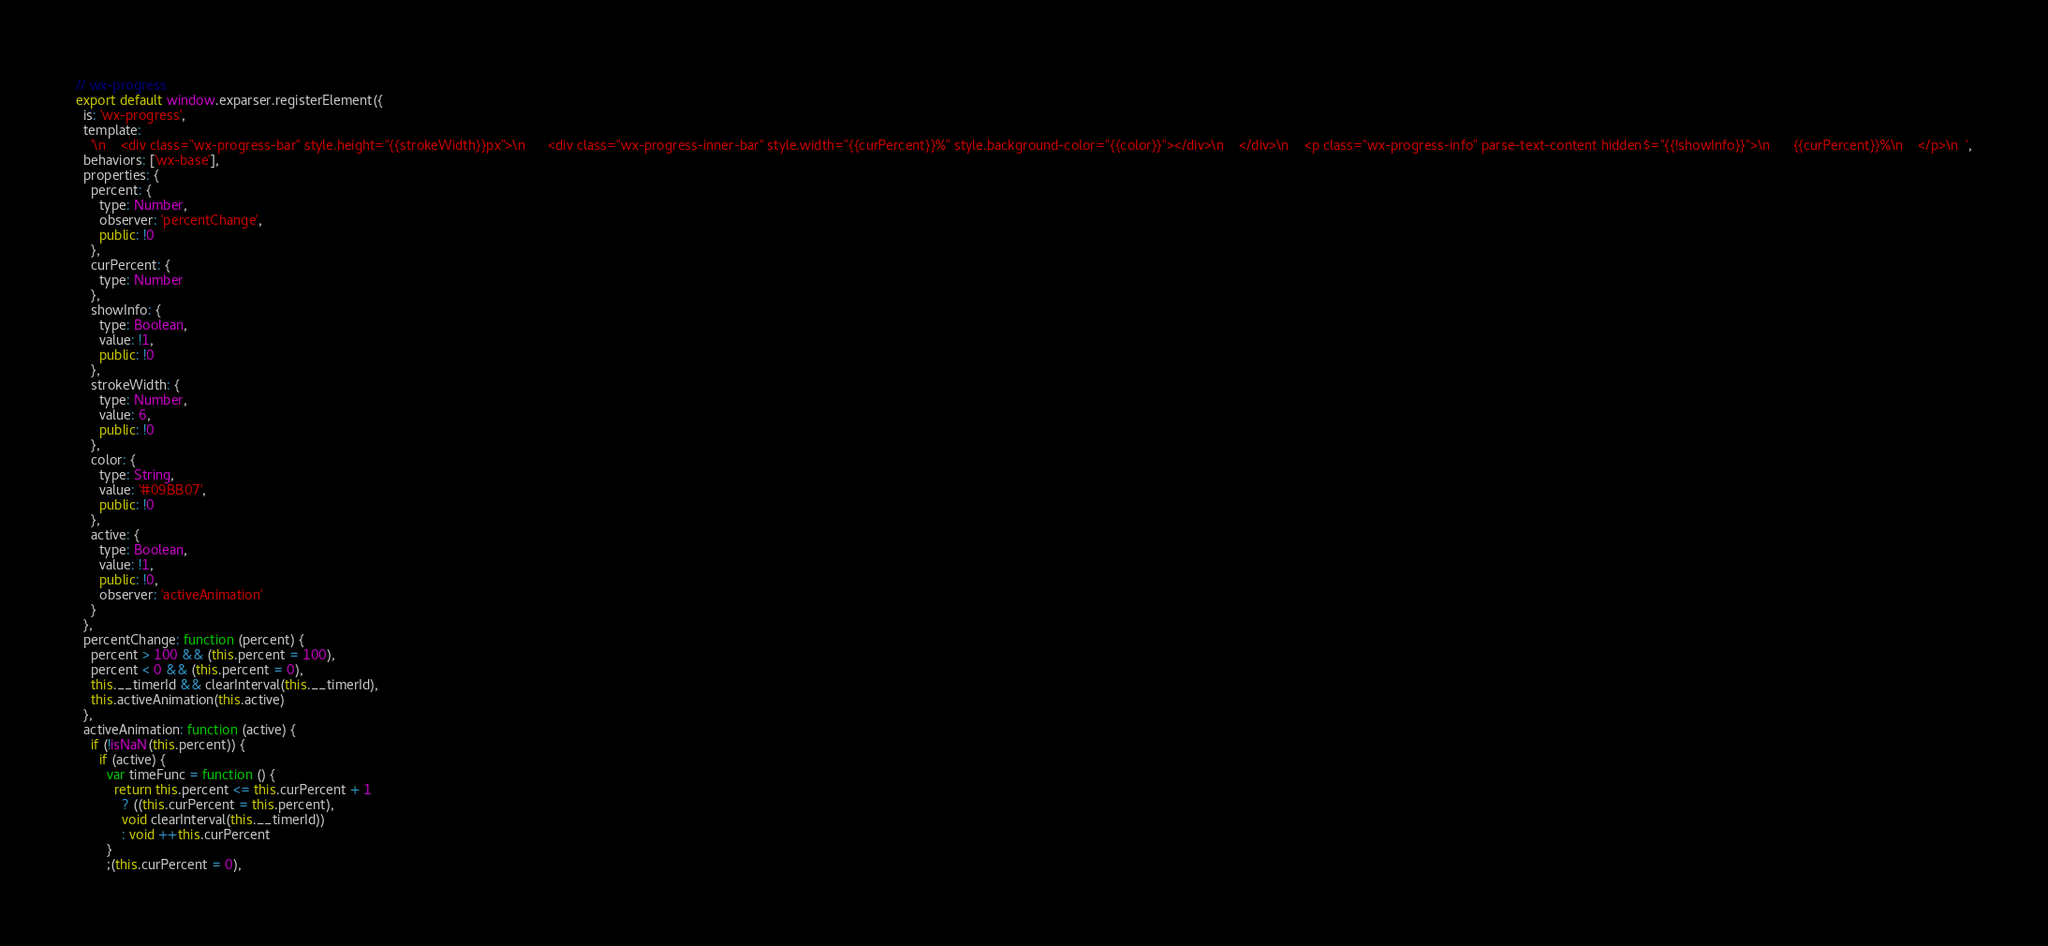<code> <loc_0><loc_0><loc_500><loc_500><_JavaScript_>// wx-progress
export default window.exparser.registerElement({
  is: 'wx-progress',
  template:
    '\n    <div class="wx-progress-bar" style.height="{{strokeWidth}}px">\n      <div class="wx-progress-inner-bar" style.width="{{curPercent}}%" style.background-color="{{color}}"></div>\n    </div>\n    <p class="wx-progress-info" parse-text-content hidden$="{{!showInfo}}">\n      {{curPercent}}%\n    </p>\n  ',
  behaviors: ['wx-base'],
  properties: {
    percent: {
      type: Number,
      observer: 'percentChange',
      public: !0
    },
    curPercent: {
      type: Number
    },
    showInfo: {
      type: Boolean,
      value: !1,
      public: !0
    },
    strokeWidth: {
      type: Number,
      value: 6,
      public: !0
    },
    color: {
      type: String,
      value: '#09BB07',
      public: !0
    },
    active: {
      type: Boolean,
      value: !1,
      public: !0,
      observer: 'activeAnimation'
    }
  },
  percentChange: function (percent) {
    percent > 100 && (this.percent = 100),
    percent < 0 && (this.percent = 0),
    this.__timerId && clearInterval(this.__timerId),
    this.activeAnimation(this.active)
  },
  activeAnimation: function (active) {
    if (!isNaN(this.percent)) {
      if (active) {
        var timeFunc = function () {
          return this.percent <= this.curPercent + 1
            ? ((this.curPercent = this.percent),
            void clearInterval(this.__timerId))
            : void ++this.curPercent
        }
        ;(this.curPercent = 0),</code> 